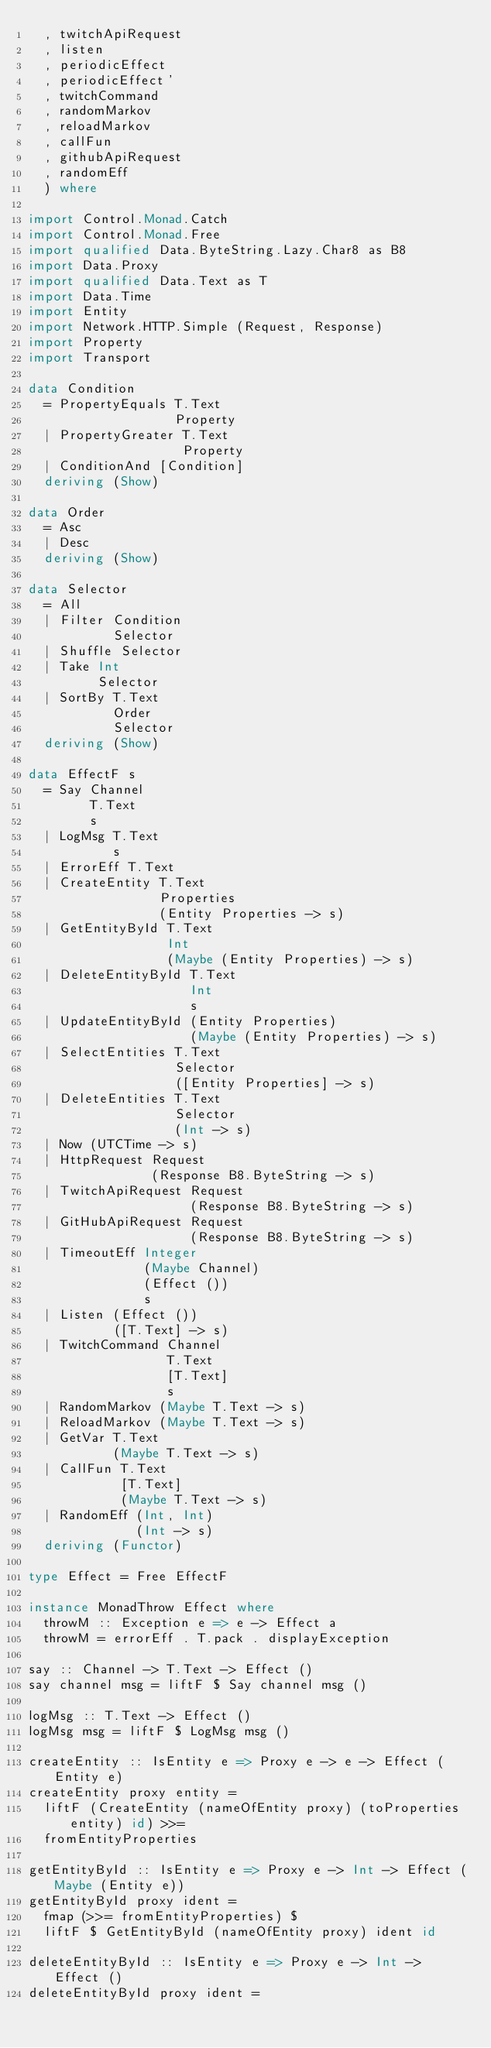Convert code to text. <code><loc_0><loc_0><loc_500><loc_500><_Haskell_>  , twitchApiRequest
  , listen
  , periodicEffect
  , periodicEffect'
  , twitchCommand
  , randomMarkov
  , reloadMarkov
  , callFun
  , githubApiRequest
  , randomEff
  ) where

import Control.Monad.Catch
import Control.Monad.Free
import qualified Data.ByteString.Lazy.Char8 as B8
import Data.Proxy
import qualified Data.Text as T
import Data.Time
import Entity
import Network.HTTP.Simple (Request, Response)
import Property
import Transport

data Condition
  = PropertyEquals T.Text
                   Property
  | PropertyGreater T.Text
                    Property
  | ConditionAnd [Condition]
  deriving (Show)

data Order
  = Asc
  | Desc
  deriving (Show)

data Selector
  = All
  | Filter Condition
           Selector
  | Shuffle Selector
  | Take Int
         Selector
  | SortBy T.Text
           Order
           Selector
  deriving (Show)

data EffectF s
  = Say Channel
        T.Text
        s
  | LogMsg T.Text
           s
  | ErrorEff T.Text
  | CreateEntity T.Text
                 Properties
                 (Entity Properties -> s)
  | GetEntityById T.Text
                  Int
                  (Maybe (Entity Properties) -> s)
  | DeleteEntityById T.Text
                     Int
                     s
  | UpdateEntityById (Entity Properties)
                     (Maybe (Entity Properties) -> s)
  | SelectEntities T.Text
                   Selector
                   ([Entity Properties] -> s)
  | DeleteEntities T.Text
                   Selector
                   (Int -> s)
  | Now (UTCTime -> s)
  | HttpRequest Request
                (Response B8.ByteString -> s)
  | TwitchApiRequest Request
                     (Response B8.ByteString -> s)
  | GitHubApiRequest Request
                     (Response B8.ByteString -> s)
  | TimeoutEff Integer
               (Maybe Channel)
               (Effect ())
               s
  | Listen (Effect ())
           ([T.Text] -> s)
  | TwitchCommand Channel
                  T.Text
                  [T.Text]
                  s
  | RandomMarkov (Maybe T.Text -> s)
  | ReloadMarkov (Maybe T.Text -> s)
  | GetVar T.Text
           (Maybe T.Text -> s)
  | CallFun T.Text
            [T.Text]
            (Maybe T.Text -> s)
  | RandomEff (Int, Int)
              (Int -> s)
  deriving (Functor)

type Effect = Free EffectF

instance MonadThrow Effect where
  throwM :: Exception e => e -> Effect a
  throwM = errorEff . T.pack . displayException

say :: Channel -> T.Text -> Effect ()
say channel msg = liftF $ Say channel msg ()

logMsg :: T.Text -> Effect ()
logMsg msg = liftF $ LogMsg msg ()

createEntity :: IsEntity e => Proxy e -> e -> Effect (Entity e)
createEntity proxy entity =
  liftF (CreateEntity (nameOfEntity proxy) (toProperties entity) id) >>=
  fromEntityProperties

getEntityById :: IsEntity e => Proxy e -> Int -> Effect (Maybe (Entity e))
getEntityById proxy ident =
  fmap (>>= fromEntityProperties) $
  liftF $ GetEntityById (nameOfEntity proxy) ident id

deleteEntityById :: IsEntity e => Proxy e -> Int -> Effect ()
deleteEntityById proxy ident =</code> 